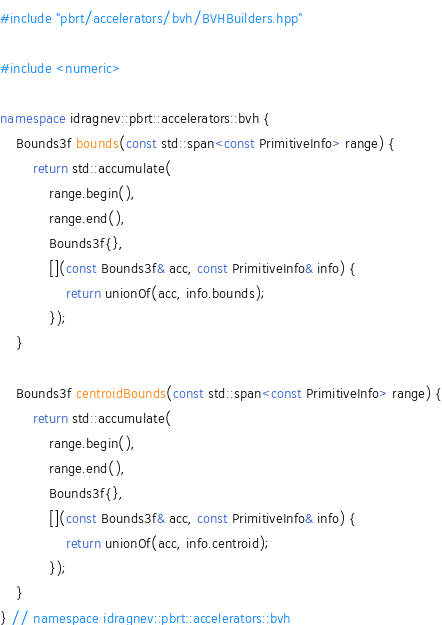Convert code to text. <code><loc_0><loc_0><loc_500><loc_500><_C++_>#include "pbrt/accelerators/bvh/BVHBuilders.hpp"

#include <numeric>

namespace idragnev::pbrt::accelerators::bvh {
    Bounds3f bounds(const std::span<const PrimitiveInfo> range) {
        return std::accumulate(
            range.begin(),
            range.end(),
            Bounds3f{},
            [](const Bounds3f& acc, const PrimitiveInfo& info) {
                return unionOf(acc, info.bounds);
            });
    }

    Bounds3f centroidBounds(const std::span<const PrimitiveInfo> range) {
        return std::accumulate(
            range.begin(),
            range.end(),
            Bounds3f{},
            [](const Bounds3f& acc, const PrimitiveInfo& info) {
                return unionOf(acc, info.centroid);
            });
    }
} // namespace idragnev::pbrt::accelerators::bvh</code> 